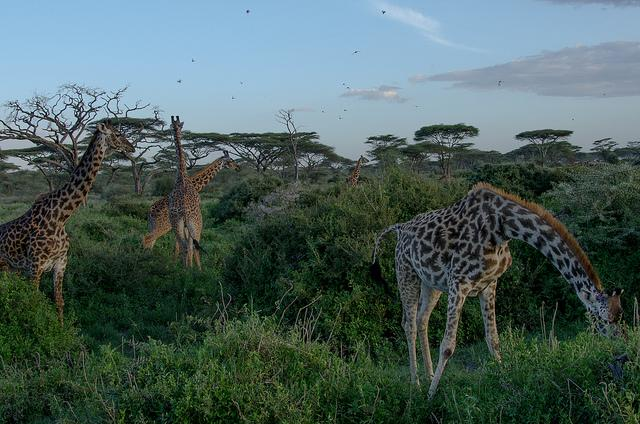How many giraffes can clearly be seen grazing in the area? one 